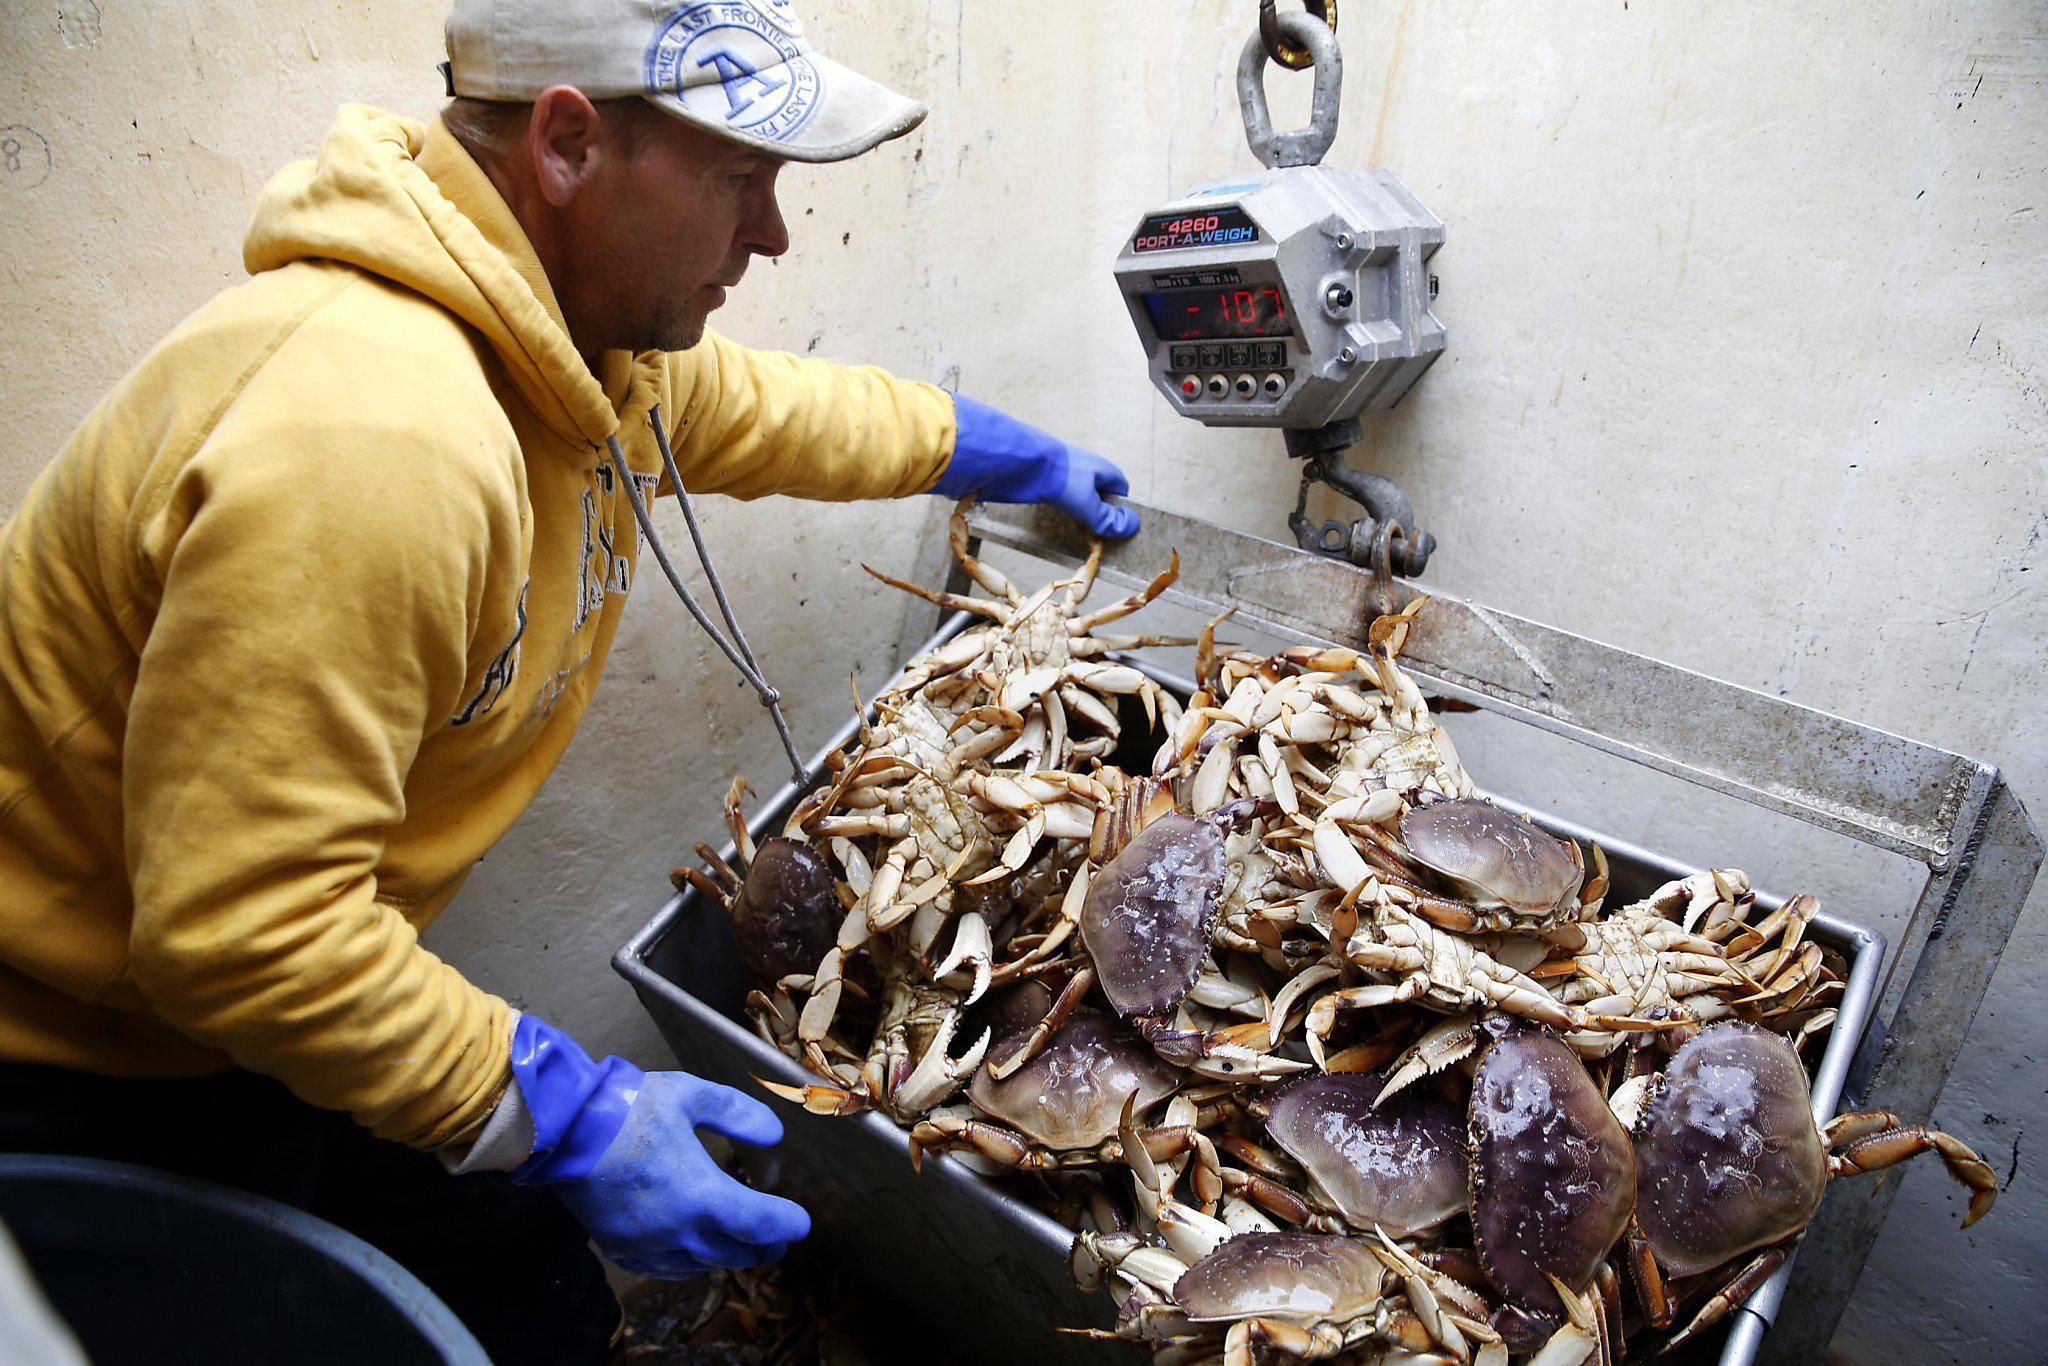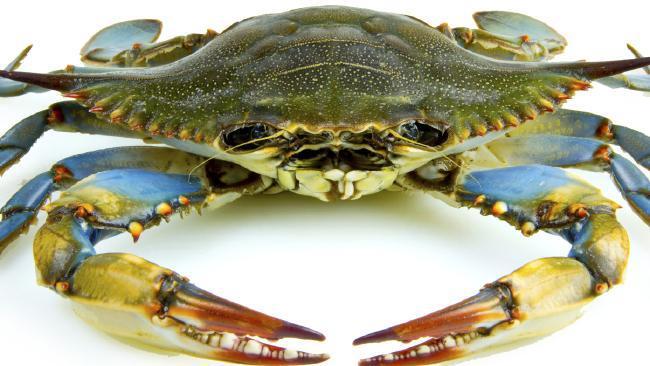The first image is the image on the left, the second image is the image on the right. Considering the images on both sides, is "One image shows a pile of shell-side up crabs without a container, and the other image shows a mass of crabs in a round container." valid? Answer yes or no. No. The first image is the image on the left, the second image is the image on the right. Analyze the images presented: Is the assertion "The crabs in one of the images are being weighed with a scale." valid? Answer yes or no. Yes. 